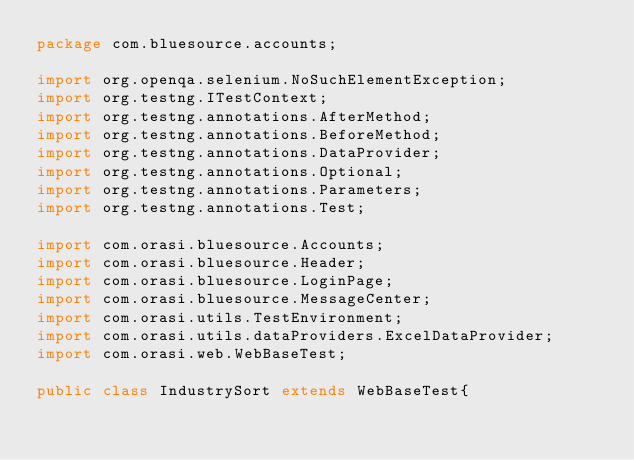Convert code to text. <code><loc_0><loc_0><loc_500><loc_500><_Java_>package com.bluesource.accounts;

import org.openqa.selenium.NoSuchElementException;
import org.testng.ITestContext;
import org.testng.annotations.AfterMethod;
import org.testng.annotations.BeforeMethod;
import org.testng.annotations.DataProvider;
import org.testng.annotations.Optional;
import org.testng.annotations.Parameters;
import org.testng.annotations.Test;

import com.orasi.bluesource.Accounts;
import com.orasi.bluesource.Header;
import com.orasi.bluesource.LoginPage;
import com.orasi.bluesource.MessageCenter;
import com.orasi.utils.TestEnvironment;
import com.orasi.utils.dataProviders.ExcelDataProvider;
import com.orasi.web.WebBaseTest;

public class IndustrySort extends WebBaseTest{

</code> 